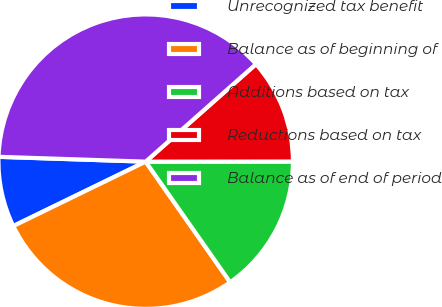<chart> <loc_0><loc_0><loc_500><loc_500><pie_chart><fcel>Unrecognized tax benefit<fcel>Balance as of beginning of<fcel>Additions based on tax<fcel>Reductions based on tax<fcel>Balance as of end of period<nl><fcel>7.73%<fcel>27.52%<fcel>15.29%<fcel>11.51%<fcel>37.96%<nl></chart> 